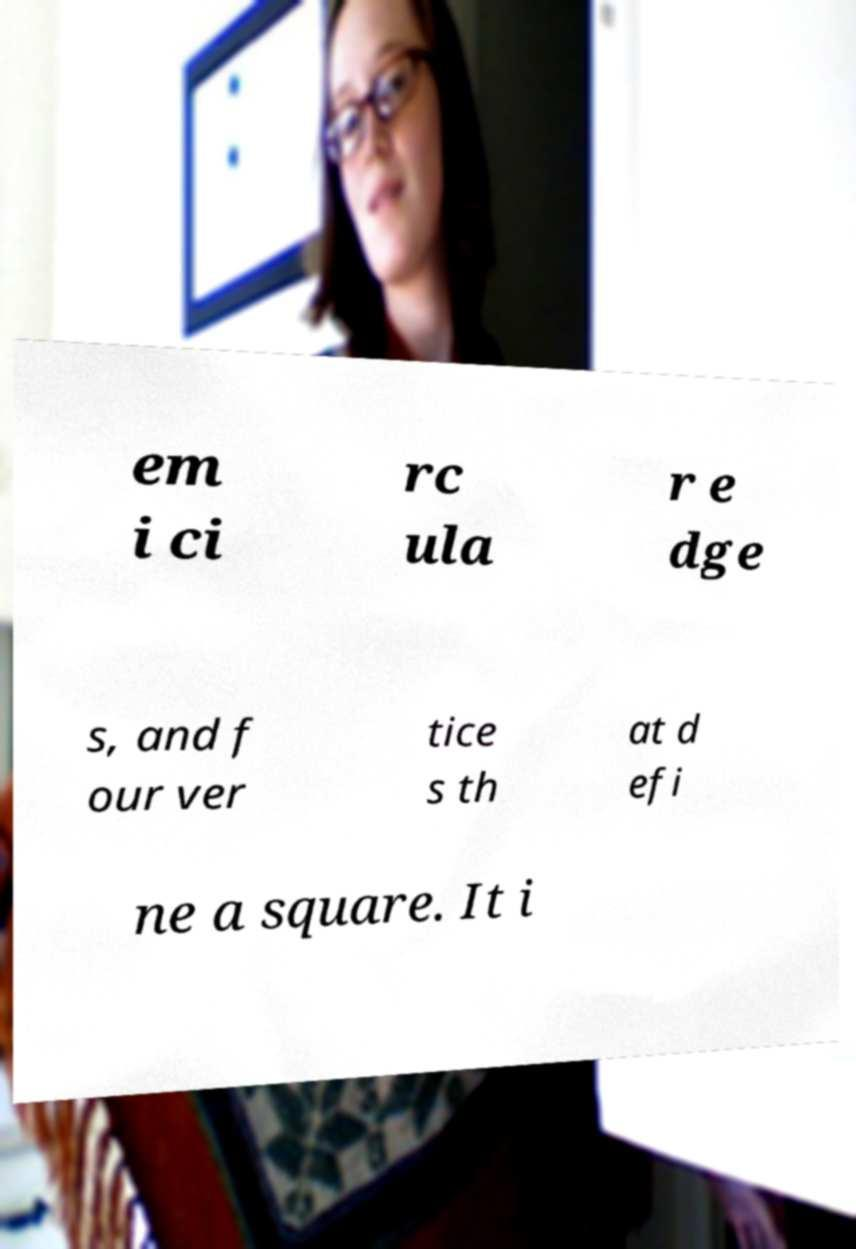Could you assist in decoding the text presented in this image and type it out clearly? em i ci rc ula r e dge s, and f our ver tice s th at d efi ne a square. It i 